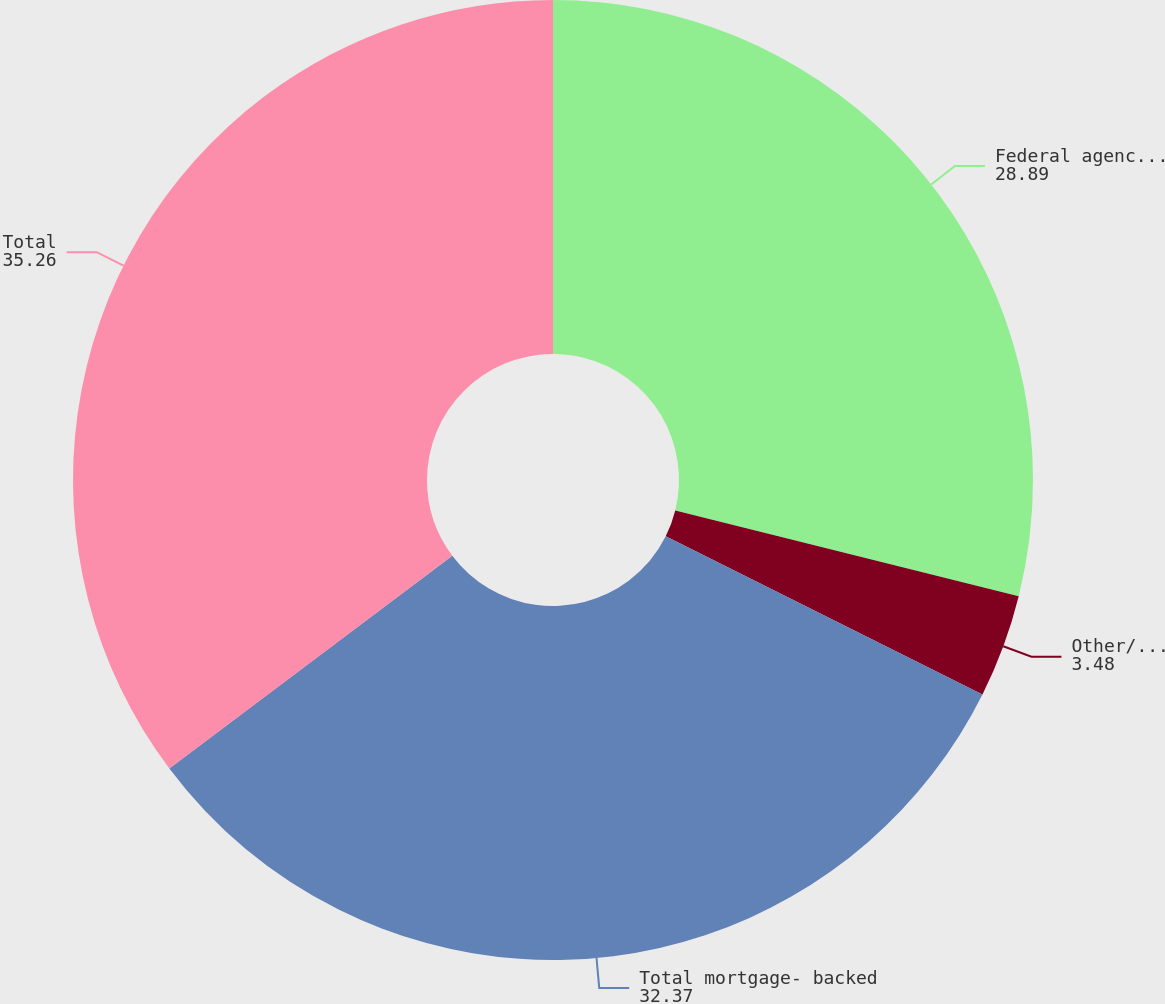<chart> <loc_0><loc_0><loc_500><loc_500><pie_chart><fcel>Federal agencies and US<fcel>Other/non-agency<fcel>Total mortgage- backed<fcel>Total<nl><fcel>28.89%<fcel>3.48%<fcel>32.37%<fcel>35.26%<nl></chart> 